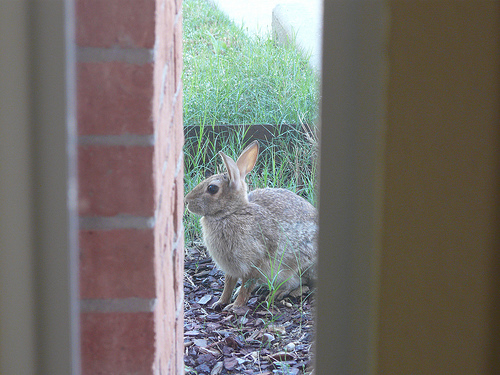<image>
Is the rabbit on the ground? Yes. Looking at the image, I can see the rabbit is positioned on top of the ground, with the ground providing support. 